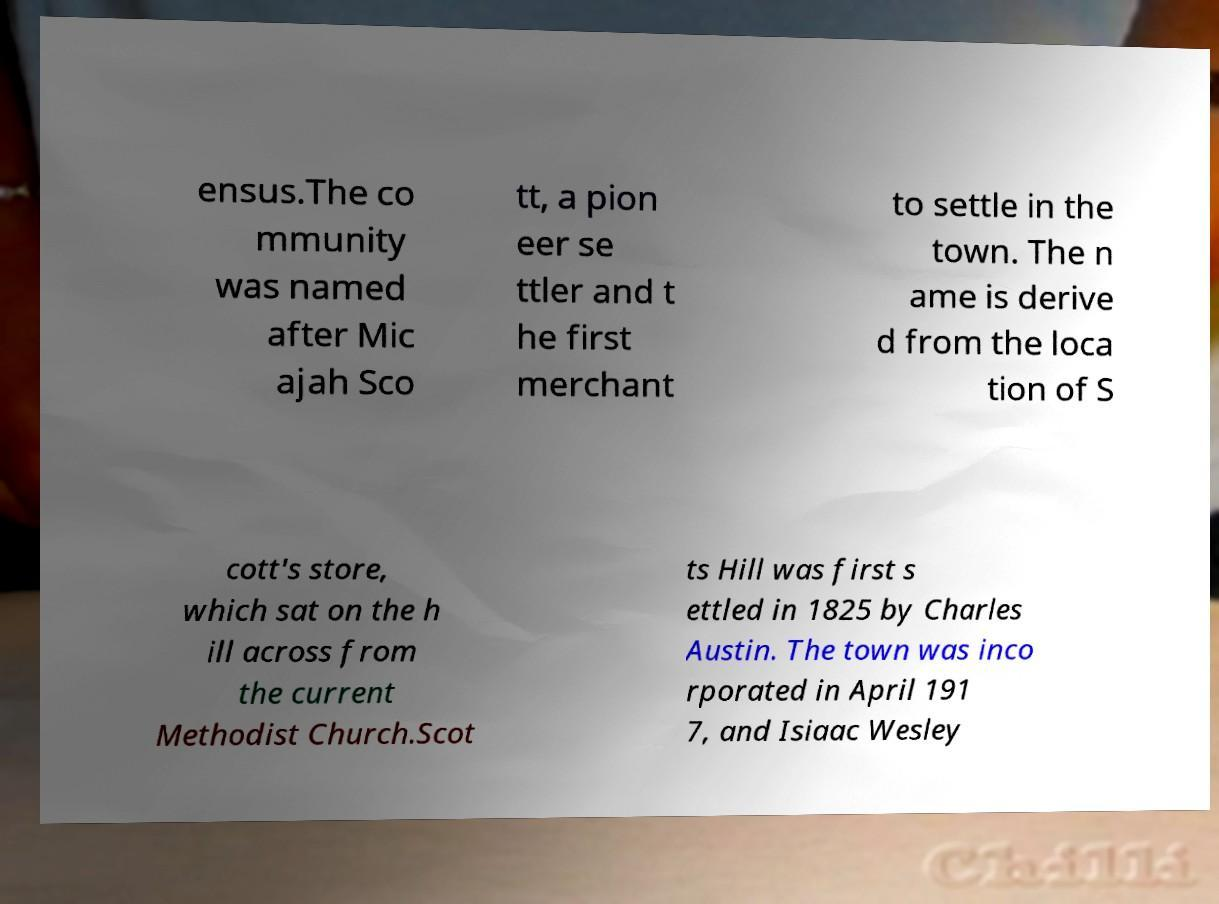What messages or text are displayed in this image? I need them in a readable, typed format. ensus.The co mmunity was named after Mic ajah Sco tt, a pion eer se ttler and t he first merchant to settle in the town. The n ame is derive d from the loca tion of S cott's store, which sat on the h ill across from the current Methodist Church.Scot ts Hill was first s ettled in 1825 by Charles Austin. The town was inco rporated in April 191 7, and Isiaac Wesley 